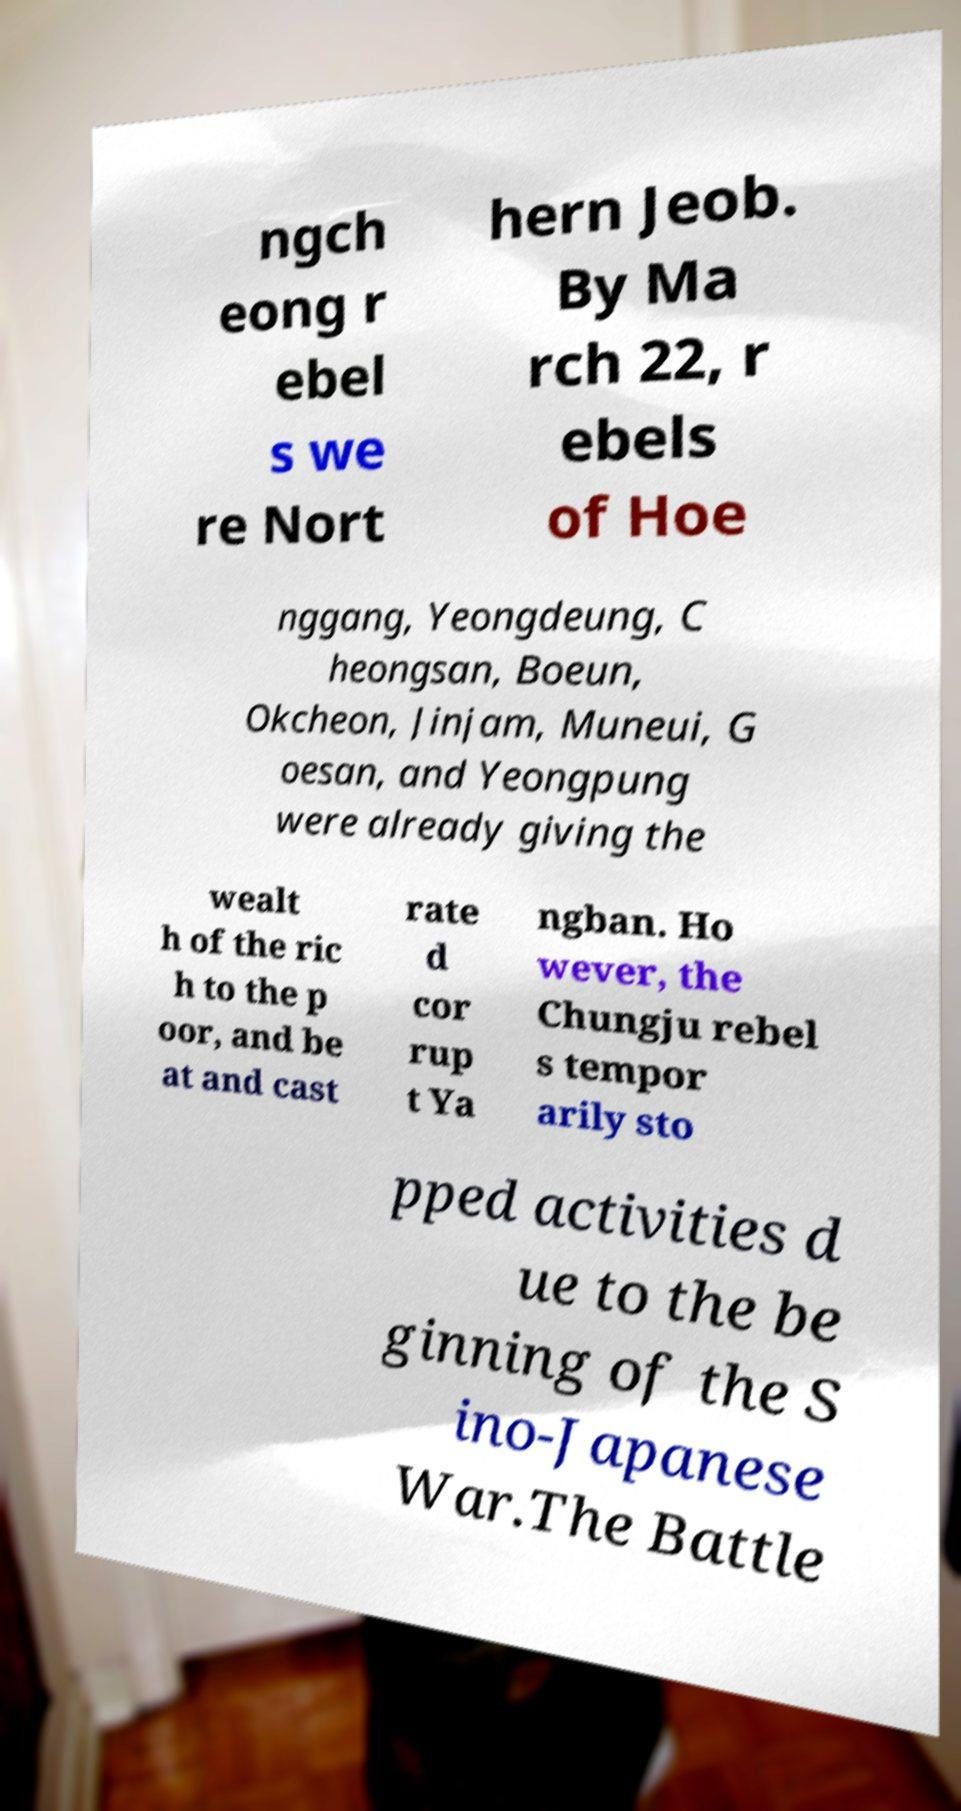Please read and relay the text visible in this image. What does it say? ngch eong r ebel s we re Nort hern Jeob. By Ma rch 22, r ebels of Hoe nggang, Yeongdeung, C heongsan, Boeun, Okcheon, Jinjam, Muneui, G oesan, and Yeongpung were already giving the wealt h of the ric h to the p oor, and be at and cast rate d cor rup t Ya ngban. Ho wever, the Chungju rebel s tempor arily sto pped activities d ue to the be ginning of the S ino-Japanese War.The Battle 